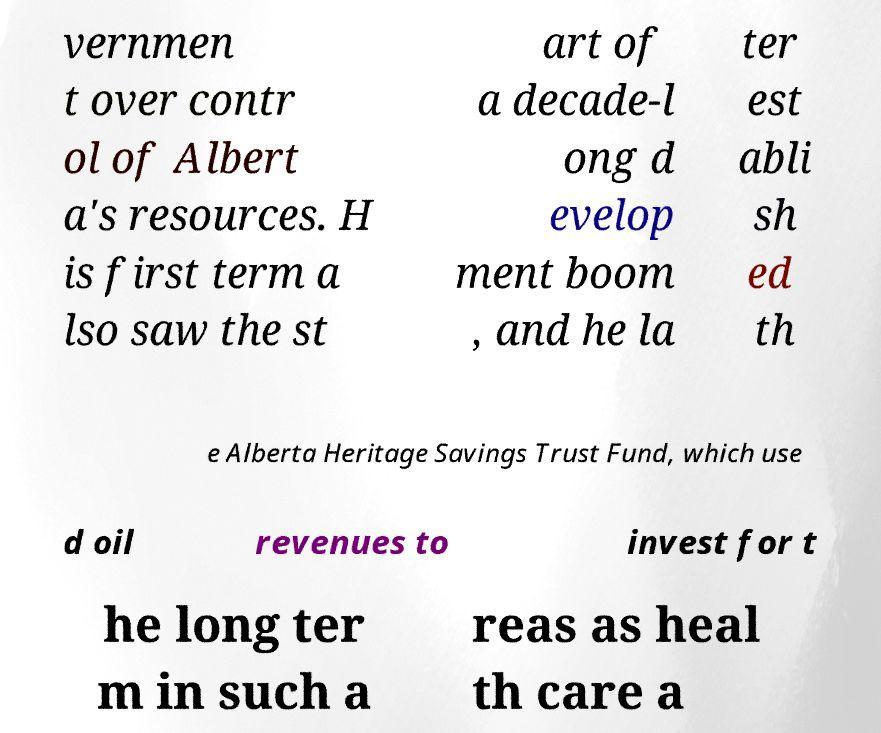Can you read and provide the text displayed in the image?This photo seems to have some interesting text. Can you extract and type it out for me? vernmen t over contr ol of Albert a's resources. H is first term a lso saw the st art of a decade-l ong d evelop ment boom , and he la ter est abli sh ed th e Alberta Heritage Savings Trust Fund, which use d oil revenues to invest for t he long ter m in such a reas as heal th care a 